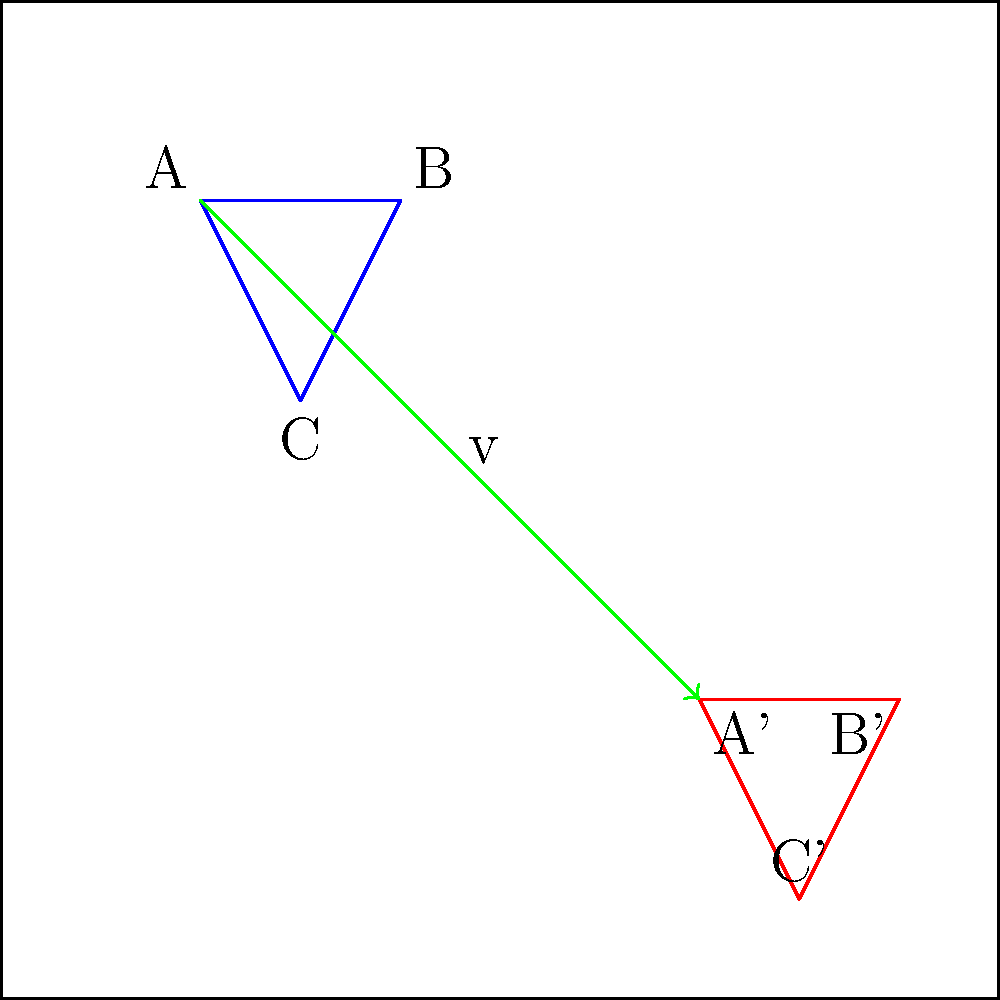As an e-commerce platform representative, you're working on updating the website layout. The marketing team wants to move the company logo to a new position on the webpage. Given that the original logo is represented by triangle ABC and needs to be translated by vector v(50, -50), what are the coordinates of point A' (the new position of point A) after the translation? To solve this problem, we need to follow these steps:

1. Identify the original coordinates of point A:
   A(20, 80)

2. Identify the translation vector:
   v(50, -50)

3. Apply the translation formula:
   For a point (x, y) translated by vector (a, b), the new coordinates are (x + a, y + b)

4. Calculate the new coordinates of A':
   x-coordinate of A': 20 + 50 = 70
   y-coordinate of A': 80 + (-50) = 30

5. Therefore, the new coordinates of A' are (70, 30)

This translation moves the logo 50 units to the right and 50 units down on the webpage layout.
Answer: (70, 30) 